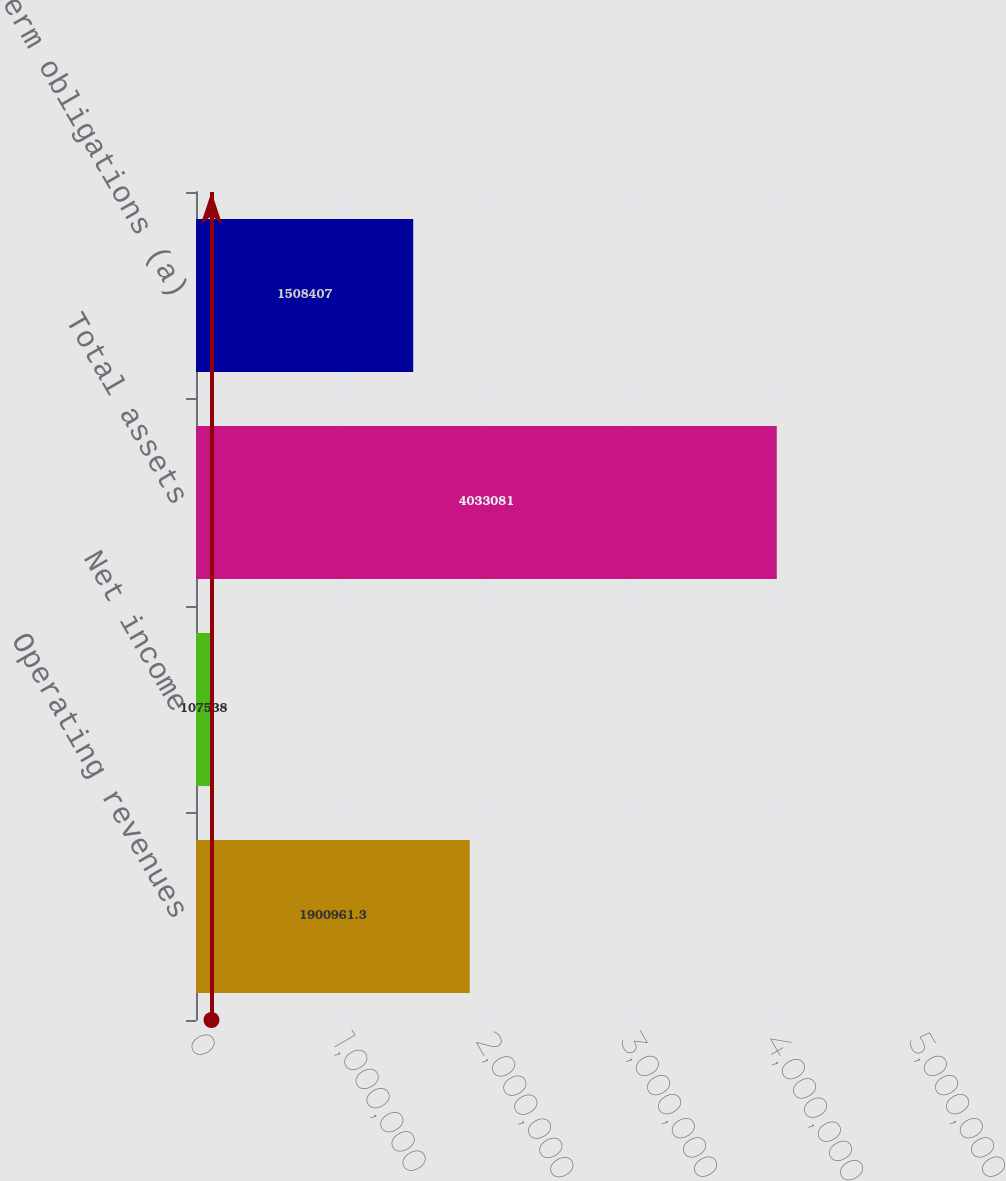Convert chart. <chart><loc_0><loc_0><loc_500><loc_500><bar_chart><fcel>Operating revenues<fcel>Net income<fcel>Total assets<fcel>Long-term obligations (a)<nl><fcel>1.90096e+06<fcel>107538<fcel>4.03308e+06<fcel>1.50841e+06<nl></chart> 